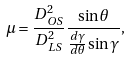Convert formula to latex. <formula><loc_0><loc_0><loc_500><loc_500>\mu = \frac { D _ { O S } ^ { 2 } } { D _ { L S } ^ { 2 } } \frac { \sin \theta } { \frac { d \gamma } { d \theta } \sin { \gamma } } ,</formula> 